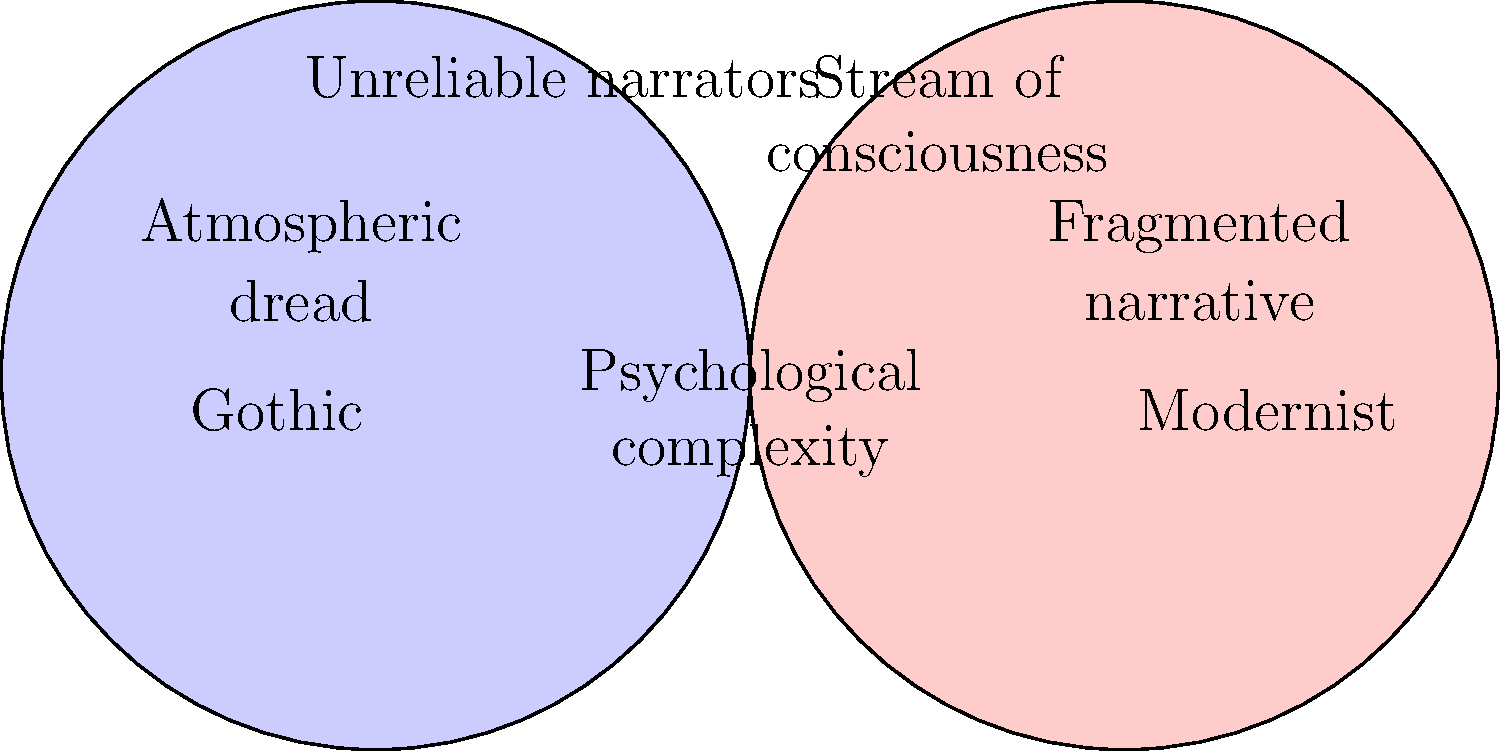Analyze the Venn diagram comparing psychological themes in Gothic and Modernist literature. Which shared element exemplifies Chesterton's narrative approach in "The Man Who Was Thursday," and how does it contribute to the novel's psychological complexity? 1. The Venn diagram shows psychological themes common to Gothic and Modernist literature.

2. The overlapping area indicates shared elements: "Psychological complexity" and "Unreliable narrators."

3. G.K. Chesterton's "The Man Who Was Thursday" blends Gothic and Modernist elements:
   a) It has Gothic elements of mystery and atmospheric dread.
   b) It incorporates Modernist techniques like fragmented narrative.

4. The key shared element relevant to Chesterton's approach is "Unreliable narrators":
   a) The protagonist, Gabriel Syme, is a police detective undercover as an anarchist.
   b) Other characters have hidden identities and motives.
   c) The narrative perspective shifts, creating uncertainty for the reader.

5. This unreliable narration contributes to psychological complexity by:
   a) Blurring the lines between reality and perception.
   b) Forcing readers to question characters' motivations and identities.
   c) Creating a sense of paranoia and distrust mirroring the characters' experiences.

6. Chesterton uses this technique to explore themes of identity, reality, and faith, adding layers of psychological depth to the novel.
Answer: Unreliable narrators, creating psychological complexity through shifting perspectives and hidden identities. 